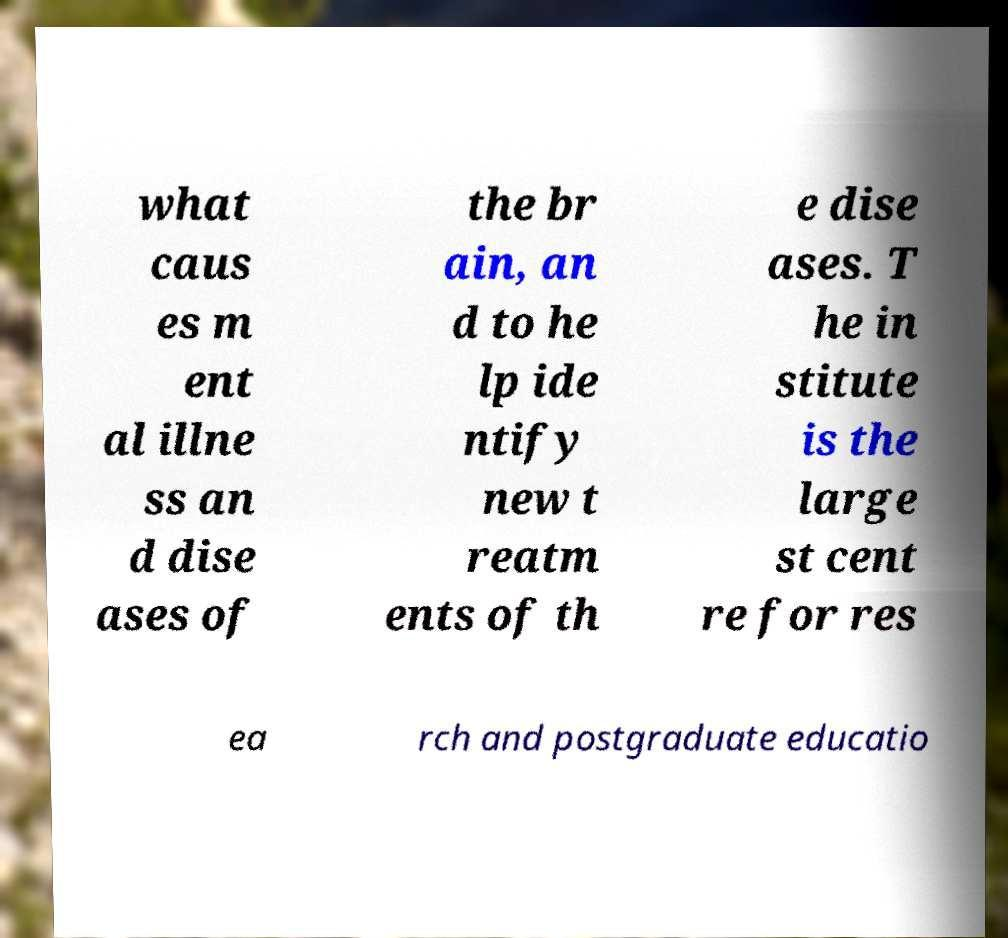There's text embedded in this image that I need extracted. Can you transcribe it verbatim? what caus es m ent al illne ss an d dise ases of the br ain, an d to he lp ide ntify new t reatm ents of th e dise ases. T he in stitute is the large st cent re for res ea rch and postgraduate educatio 